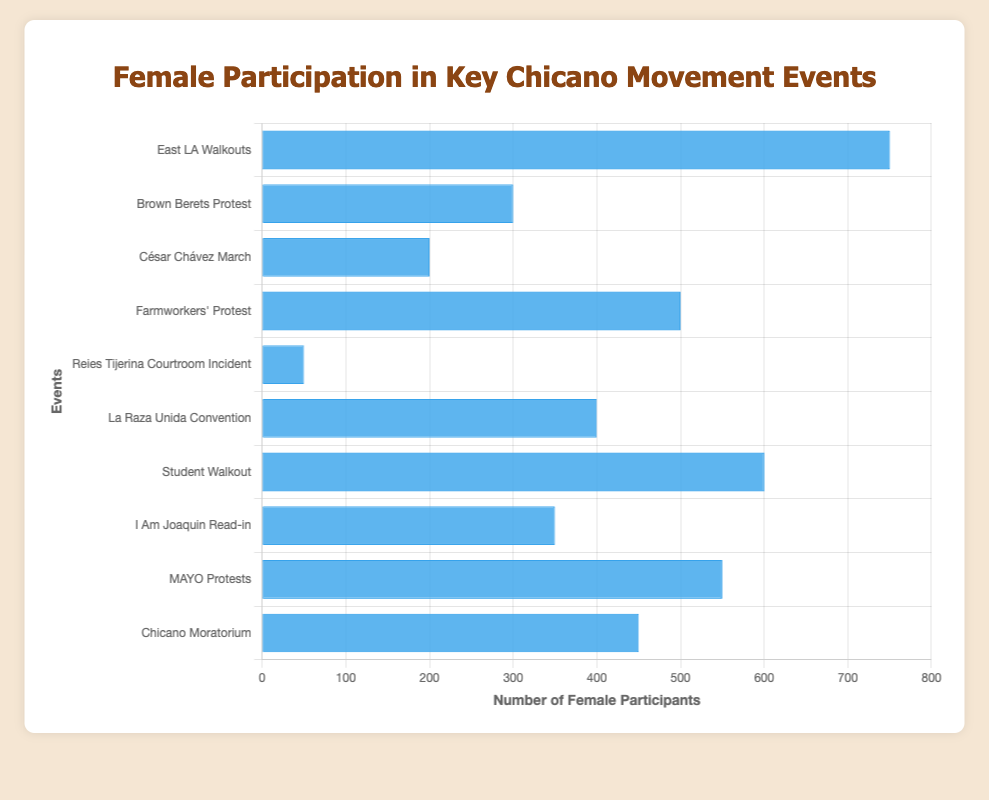Which event had the highest female participation? The bar labeled "East LA Walkouts" is the tallest, indicating the highest value.
Answer: East LA Walkouts Which event had the lowest female participation? The bar labeled "Reies Tijerina Courtroom Incident" is the shortest, indicating the lowest value.
Answer: Reies Tijerina Courtroom Incident How many females participated in the San Antonio events combined? Add the female participants from "Farmworkers' Protest" (500) and "MAYO Protests" (550). 500 + 550 = 1050
Answer: 1050 Which event in Texas had more female participants, "Farmworkers' Protest" or "La Raza Unida Convention"? Compare the heights of the bars labeled "Farmworkers' Protest" (500) and "La Raza Unida Convention" (400). The "Farmworkers' Protest" bar is taller.
Answer: Farmworkers' Protest What is the average female participation for events held in California? Sum the female participants from events in California: "East LA Walkouts" (750) + "Brown Berets Protest" (300) + "César Chávez March" (200) + "Chicano Moratorium" (450) = 1700. Divide by the number of events (4): 1700 / 4 = 425
Answer: 425 How many more female participants were there at the "East LA Walkouts" compared to the "I Am Joaquin Read-in"? Subtract the female participants for "I Am Joaquin Read-in" (350) from "East LA Walkouts" (750): 750 - 350 = 400
Answer: 400 Which has more female participants, the "Chicano Moratorium" or the "Student Walkout"? Compare the heights of the bars labeled "Chicano Moratorium" (450) and "Student Walkout" (600). The "Student Walkout" bar is taller.
Answer: Student Walkout What's the total female participation for events involving César Chávez? There's only one event, "César Chávez March", with 200 female participants.
Answer: 200 What is the combined female participation of the New Mexico events? Sum the female participants from "Reies Tijerina Courtroom Incident" (50) and "I Am Joaquin Read-in" (350): 50 + 350 = 400
Answer: 400 Among the key events, which one had the closest female participation to 500? Compare the values to 500: "Farmworkers' Protest" (500), "MAYO Protests" (550), "La Raza Unida Convention" (400), and "Chicano Moratorium" (450). The "Farmworkers' Protest" has exactly 500 participants.
Answer: Farmworkers' Protest 